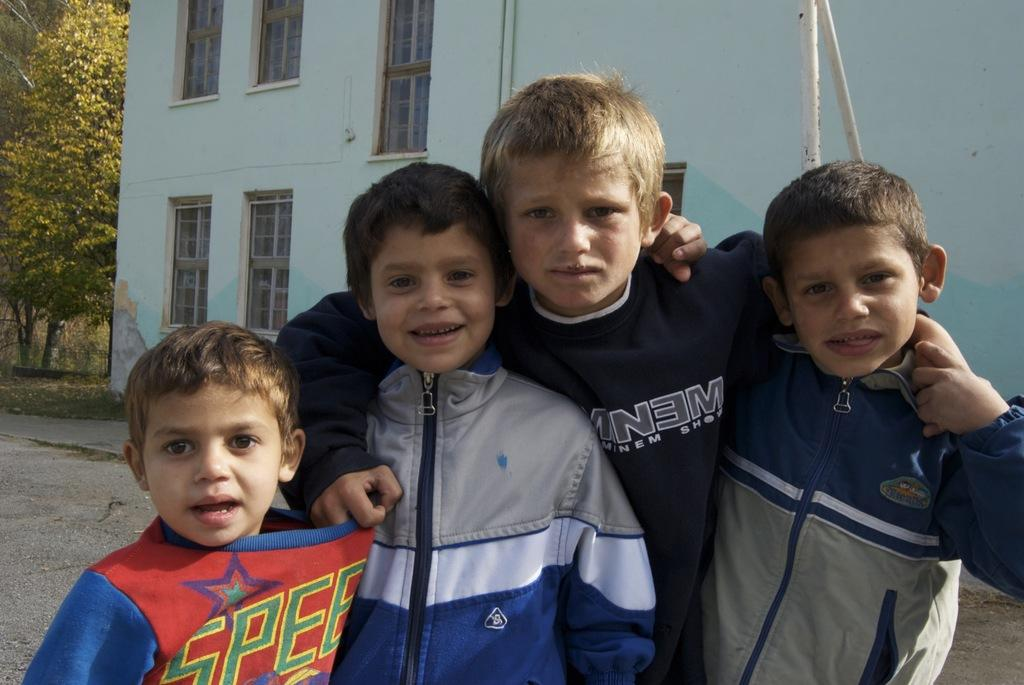<image>
Offer a succinct explanation of the picture presented. One boy wearing an Eminem Show shirt is surrounded by three other boys. 